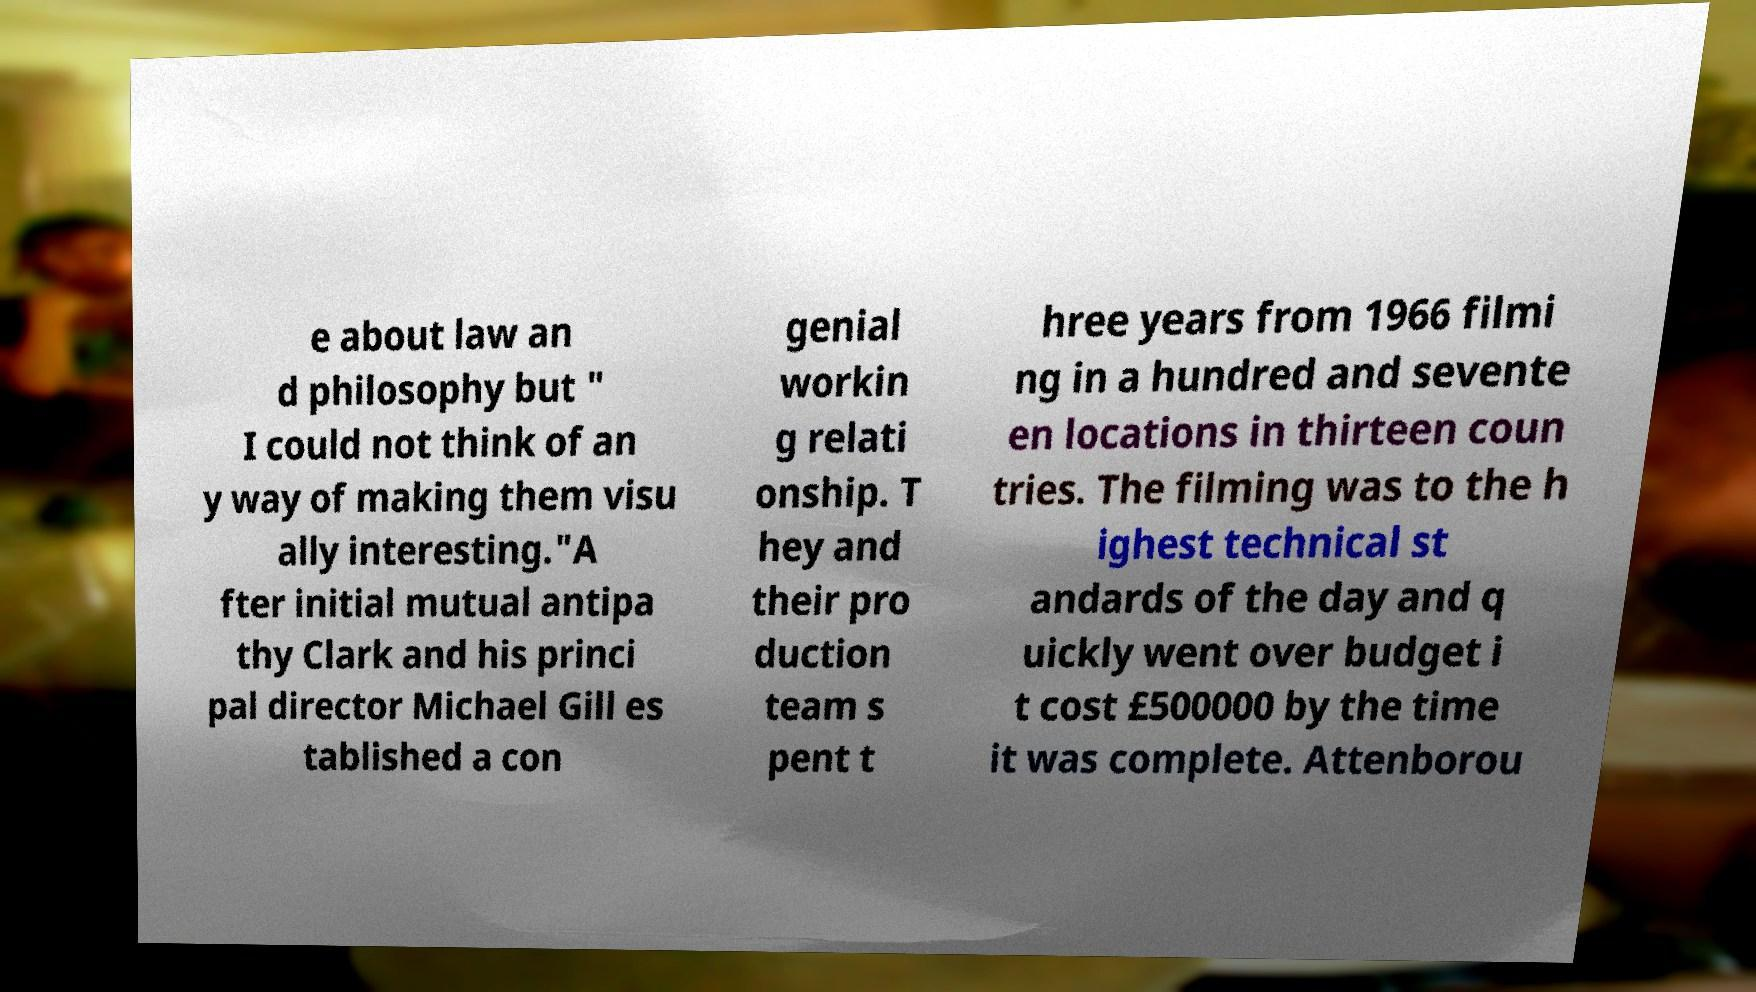Could you extract and type out the text from this image? e about law an d philosophy but " I could not think of an y way of making them visu ally interesting."A fter initial mutual antipa thy Clark and his princi pal director Michael Gill es tablished a con genial workin g relati onship. T hey and their pro duction team s pent t hree years from 1966 filmi ng in a hundred and sevente en locations in thirteen coun tries. The filming was to the h ighest technical st andards of the day and q uickly went over budget i t cost £500000 by the time it was complete. Attenborou 